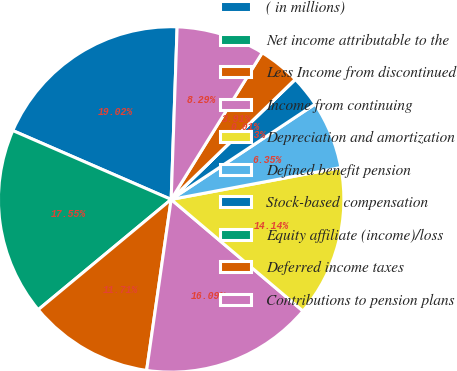<chart> <loc_0><loc_0><loc_500><loc_500><pie_chart><fcel>( in millions)<fcel>Net income attributable to the<fcel>Less Income from discontinued<fcel>Income from continuing<fcel>Depreciation and amortization<fcel>Defined benefit pension<fcel>Stock-based compensation<fcel>Equity affiliate (income)/loss<fcel>Deferred income taxes<fcel>Contributions to pension plans<nl><fcel>19.02%<fcel>17.55%<fcel>11.71%<fcel>16.09%<fcel>14.14%<fcel>6.35%<fcel>2.93%<fcel>0.01%<fcel>3.91%<fcel>8.29%<nl></chart> 